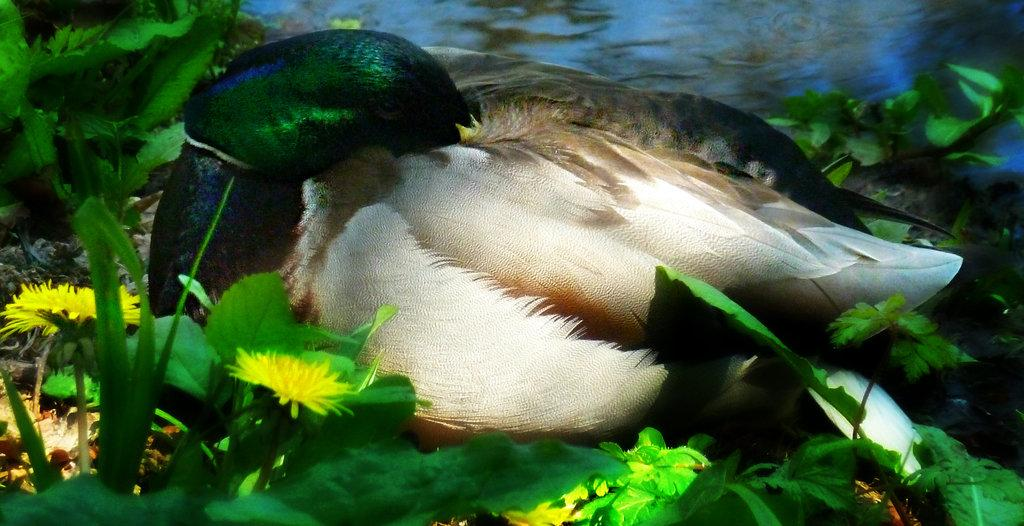What is the main subject in the center of the image? There is a bird in the center of the image. What type of vegetation can be seen in the image? There are plants with flowers in the image. What else is visible in the image besides the bird and plants? There is water visible in the image. How many parents can be seen in the image? There are no parents visible in the image; it features a bird and plants with flowers. What type of flower is present in the fifth plant in the image? There is no information about the number of plants or their specific flowers in the image. 